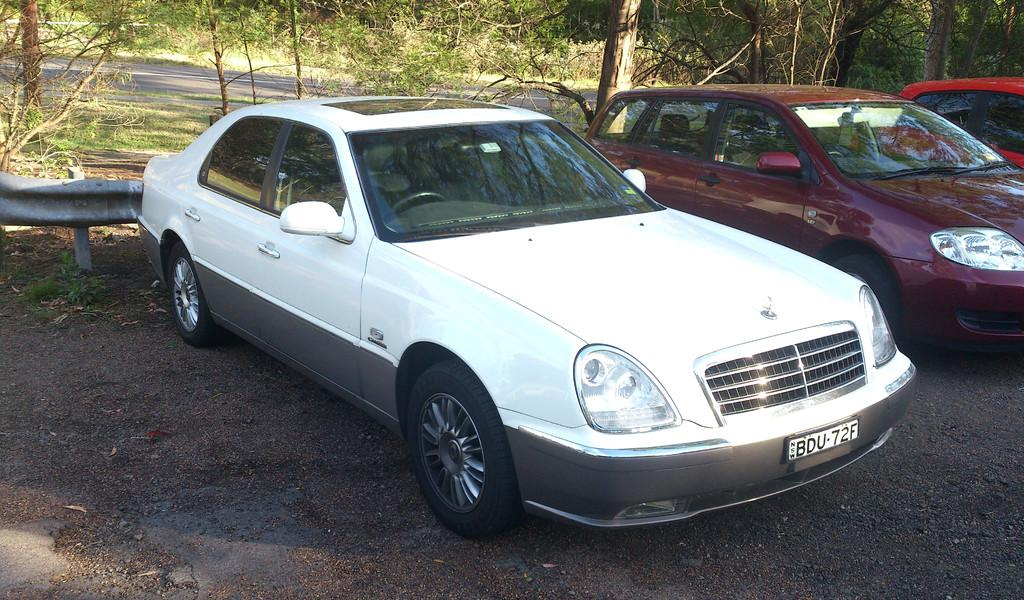How many cars can be seen on the road in the image? There are 3 cars on the road in the image. What is the main feature of the image? The main feature of the image is a road. What can be seen in the background of the image? Trees are present at the back (presumably referring to the background) of the image. What type of lipstick is being discussed in the image? There is no lipstick or discussion present in the image. What selection of items is being made in the image? There is no selection of items being made in the image. 